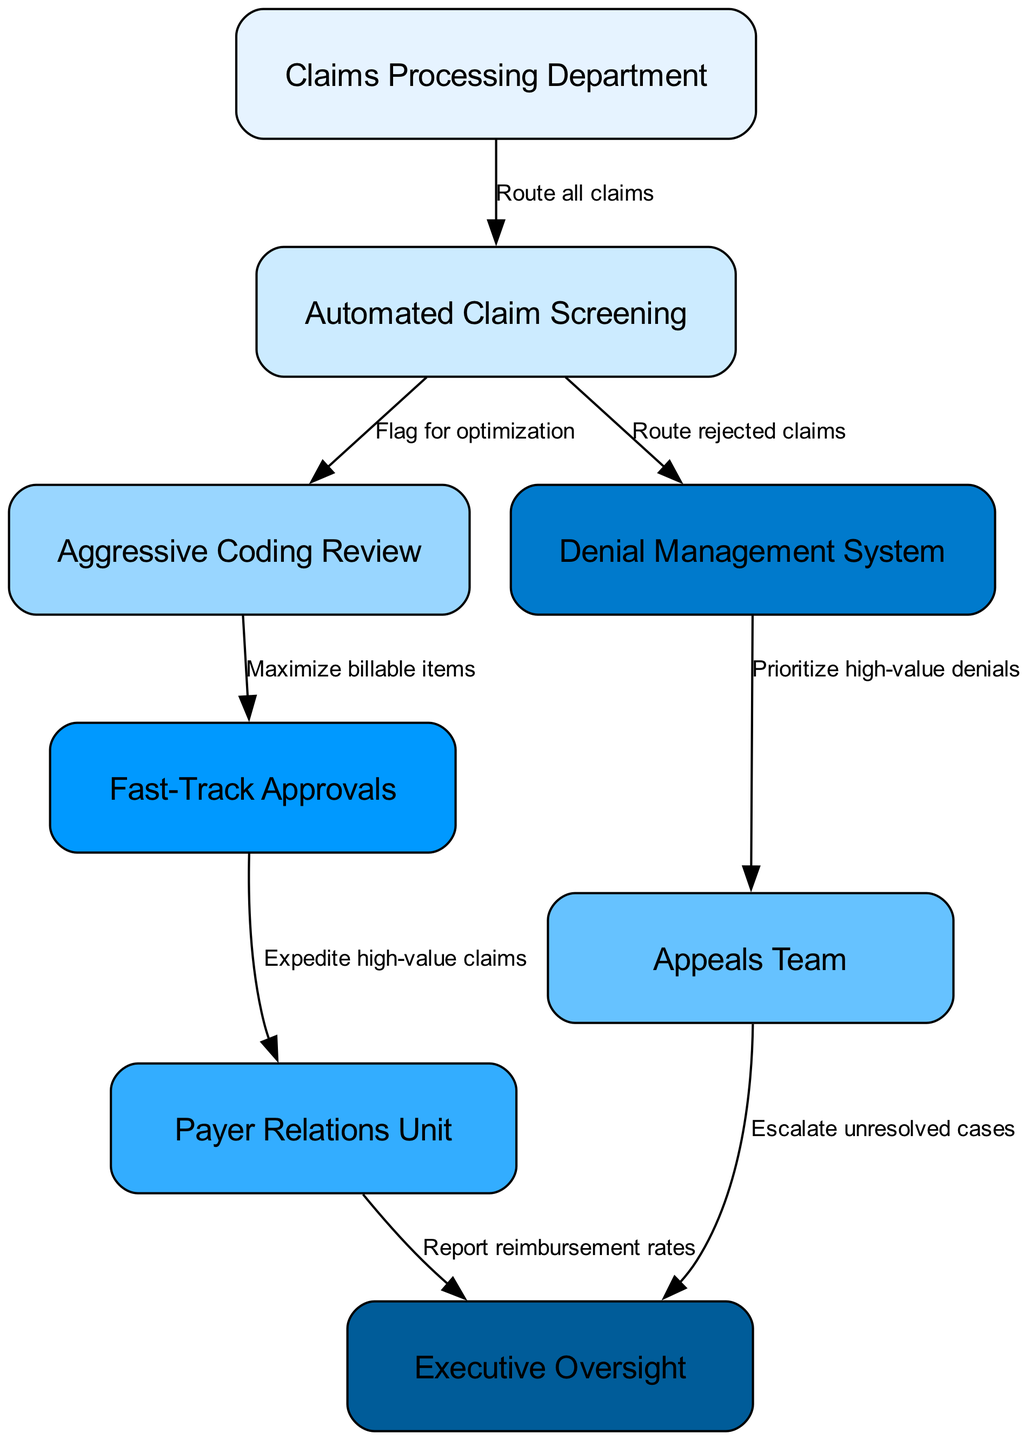What department routes all claims? The diagram shows that the "Claims Processing Department" is the starting point for routing all claims, as indicated by the first edge leading from it.
Answer: Claims Processing Department How many nodes are in the diagram? By counting the unique departments and processes listed in the nodes array, we find there are eight nodes represented in the diagram.
Answer: 8 What does Automated Claim Screening flag for? The edge from "Automated Claim Screening" to "Aggressive Coding Review" is labeled "Flag for optimization," indicating this is the focus of the Automated Claim Screening.
Answer: Optimization Which unit expedites high-value claims? The arrow pointing from "Fast-Track Approvals" to "Payer Relations Unit" shows that the purpose of the Fast-Track Approvals is to expedite these claims, as labeled in the diagram.
Answer: Payer Relations Unit What is the output of the Appeals Team? The Appeals Team outputs unresolved cases to the "Executive Oversight" department, as indicated by the respective edge connecting them, which is labeled "Escalate unresolved cases."
Answer: Executive Oversight Which system routes rejected claims? The diagram illustrates that the "Automated Claim Screening" directs rejected claims to the "Denial Management System," represented by the labeled edge leading to it.
Answer: Denial Management System What is prioritized by the Denial Management System? The edge from "Denial Management System" to "Appeals Team" indicates that the Denial Management System prioritizes "high-value denials," as described in the diagram.
Answer: High-value denials What department reports reimbursement rates? The diagram shows that the "Payer Relations Unit" has an outgoing edge to "Executive Oversight," labeled "Report reimbursement rates," designating it as the reporting department.
Answer: Payer Relations Unit How many edges are in the diagram? By counting the connections between the nodes, we identify that there are seven edges present in the diagram.
Answer: 7 